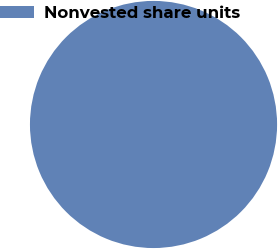Convert chart. <chart><loc_0><loc_0><loc_500><loc_500><pie_chart><fcel>Nonvested share units<nl><fcel>100.0%<nl></chart> 